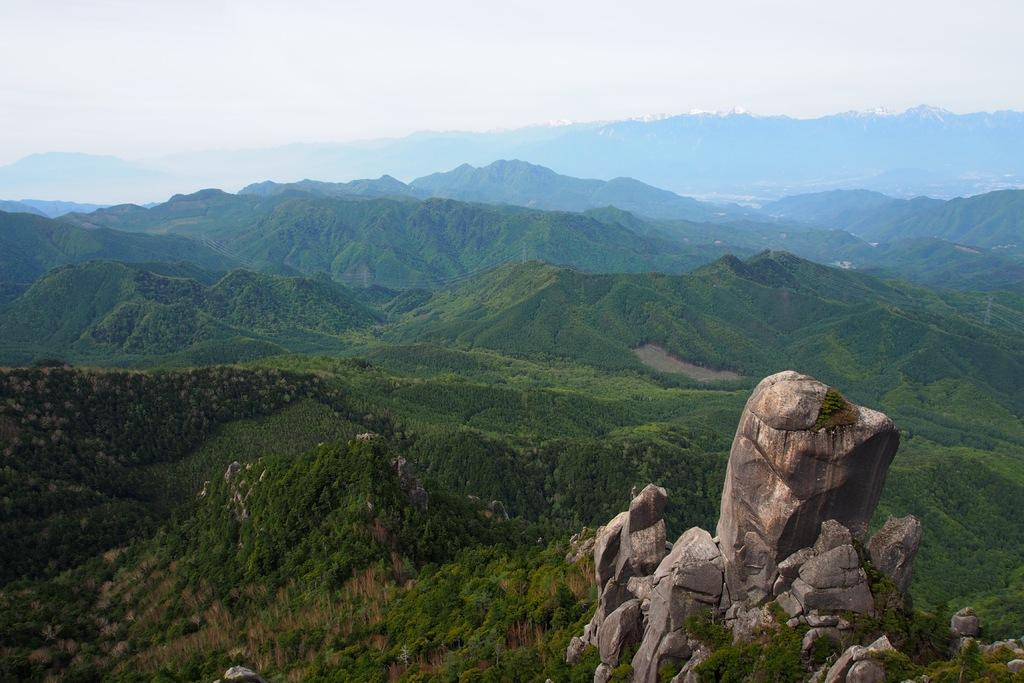What is located at the bottom of the image? There are rocks at the bottom of the image. What type of natural formation can be seen in the background of the image? There are mountains in the background of the image. What part of the natural environment is visible in the background of the image? The sky is visible in the background of the image. What type of furniture can be seen in the bedroom in the image? There is no bedroom present in the image; it features rocks at the bottom and mountains in the background. How does the rainstorm affect the rocks in the image? There is no rainstorm present in the image; it is a landscape featuring rocks, mountains, and the sky. 